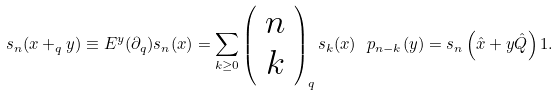Convert formula to latex. <formula><loc_0><loc_0><loc_500><loc_500>s _ { n } ( x + _ { q } y ) \equiv E ^ { y } ( \partial _ { q } ) s _ { n } ( x ) = \sum _ { k \geq 0 } \left ( \begin{array} { c } n \\ k \end{array} \right ) _ { q } s _ { k } ( x ) \ p _ { n - k } ( y ) = s _ { n } \left ( \hat { x } + y \hat { Q } \right ) 1 .</formula> 